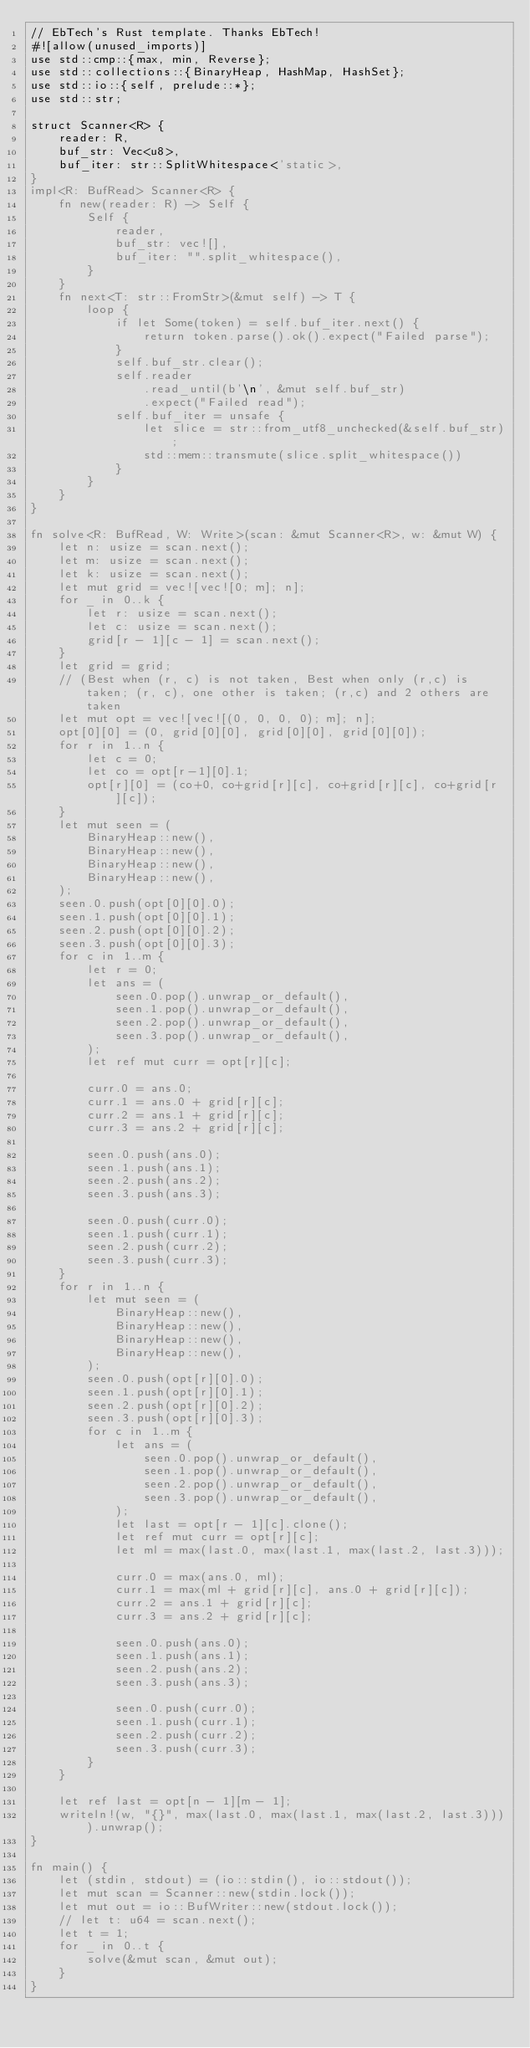Convert code to text. <code><loc_0><loc_0><loc_500><loc_500><_Rust_>// EbTech's Rust template. Thanks EbTech!
#![allow(unused_imports)]
use std::cmp::{max, min, Reverse};
use std::collections::{BinaryHeap, HashMap, HashSet};
use std::io::{self, prelude::*};
use std::str;

struct Scanner<R> {
    reader: R,
    buf_str: Vec<u8>,
    buf_iter: str::SplitWhitespace<'static>,
}
impl<R: BufRead> Scanner<R> {
    fn new(reader: R) -> Self {
        Self {
            reader,
            buf_str: vec![],
            buf_iter: "".split_whitespace(),
        }
    }
    fn next<T: str::FromStr>(&mut self) -> T {
        loop {
            if let Some(token) = self.buf_iter.next() {
                return token.parse().ok().expect("Failed parse");
            }
            self.buf_str.clear();
            self.reader
                .read_until(b'\n', &mut self.buf_str)
                .expect("Failed read");
            self.buf_iter = unsafe {
                let slice = str::from_utf8_unchecked(&self.buf_str);
                std::mem::transmute(slice.split_whitespace())
            }
        }
    }
}

fn solve<R: BufRead, W: Write>(scan: &mut Scanner<R>, w: &mut W) {
    let n: usize = scan.next();
    let m: usize = scan.next();
    let k: usize = scan.next();
    let mut grid = vec![vec![0; m]; n];
    for _ in 0..k {
        let r: usize = scan.next();
        let c: usize = scan.next();
        grid[r - 1][c - 1] = scan.next();
    }
    let grid = grid;
    // (Best when (r, c) is not taken, Best when only (r,c) is taken; (r, c), one other is taken; (r,c) and 2 others are taken
    let mut opt = vec![vec![(0, 0, 0, 0); m]; n];
    opt[0][0] = (0, grid[0][0], grid[0][0], grid[0][0]);
    for r in 1..n {
        let c = 0;
        let co = opt[r-1][0].1;
        opt[r][0] = (co+0, co+grid[r][c], co+grid[r][c], co+grid[r][c]);
    }
    let mut seen = (
        BinaryHeap::new(),
        BinaryHeap::new(),
        BinaryHeap::new(),
        BinaryHeap::new(),
    );
    seen.0.push(opt[0][0].0);
    seen.1.push(opt[0][0].1);
    seen.2.push(opt[0][0].2);
    seen.3.push(opt[0][0].3);
    for c in 1..m {
        let r = 0;
        let ans = (
            seen.0.pop().unwrap_or_default(),
            seen.1.pop().unwrap_or_default(),
            seen.2.pop().unwrap_or_default(),
            seen.3.pop().unwrap_or_default(),
        );
        let ref mut curr = opt[r][c];

        curr.0 = ans.0;
        curr.1 = ans.0 + grid[r][c];
        curr.2 = ans.1 + grid[r][c];
        curr.3 = ans.2 + grid[r][c];

        seen.0.push(ans.0);
        seen.1.push(ans.1);
        seen.2.push(ans.2);
        seen.3.push(ans.3);

        seen.0.push(curr.0);
        seen.1.push(curr.1);
        seen.2.push(curr.2);
        seen.3.push(curr.3);
    }
    for r in 1..n {
        let mut seen = (
            BinaryHeap::new(),
            BinaryHeap::new(),
            BinaryHeap::new(),
            BinaryHeap::new(),
        );
        seen.0.push(opt[r][0].0);
        seen.1.push(opt[r][0].1);
        seen.2.push(opt[r][0].2);
        seen.3.push(opt[r][0].3);
        for c in 1..m {
            let ans = (
                seen.0.pop().unwrap_or_default(),
                seen.1.pop().unwrap_or_default(),
                seen.2.pop().unwrap_or_default(),
                seen.3.pop().unwrap_or_default(),
            );
            let last = opt[r - 1][c].clone();
            let ref mut curr = opt[r][c];
            let ml = max(last.0, max(last.1, max(last.2, last.3)));
            
            curr.0 = max(ans.0, ml);
            curr.1 = max(ml + grid[r][c], ans.0 + grid[r][c]);
            curr.2 = ans.1 + grid[r][c];
            curr.3 = ans.2 + grid[r][c];

            seen.0.push(ans.0);
            seen.1.push(ans.1);
            seen.2.push(ans.2);
            seen.3.push(ans.3);

            seen.0.push(curr.0);
            seen.1.push(curr.1);
            seen.2.push(curr.2);
            seen.3.push(curr.3);
        }
    }

    let ref last = opt[n - 1][m - 1];
    writeln!(w, "{}", max(last.0, max(last.1, max(last.2, last.3)))).unwrap();
}

fn main() {
    let (stdin, stdout) = (io::stdin(), io::stdout());
    let mut scan = Scanner::new(stdin.lock());
    let mut out = io::BufWriter::new(stdout.lock());
    // let t: u64 = scan.next();
    let t = 1;
    for _ in 0..t {
        solve(&mut scan, &mut out);
    }
}
</code> 